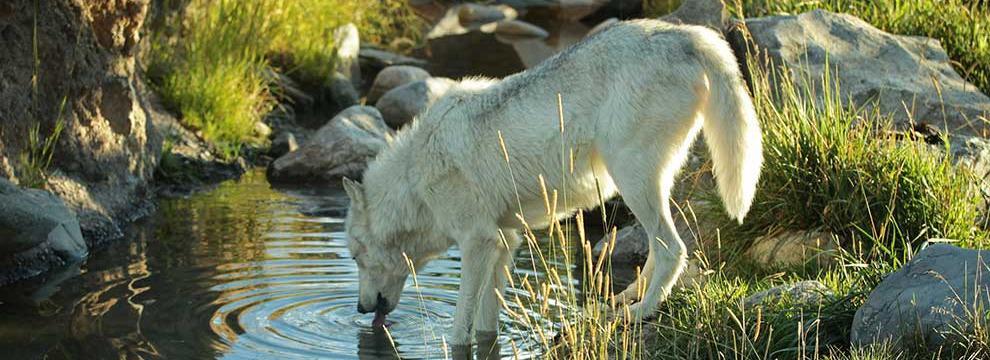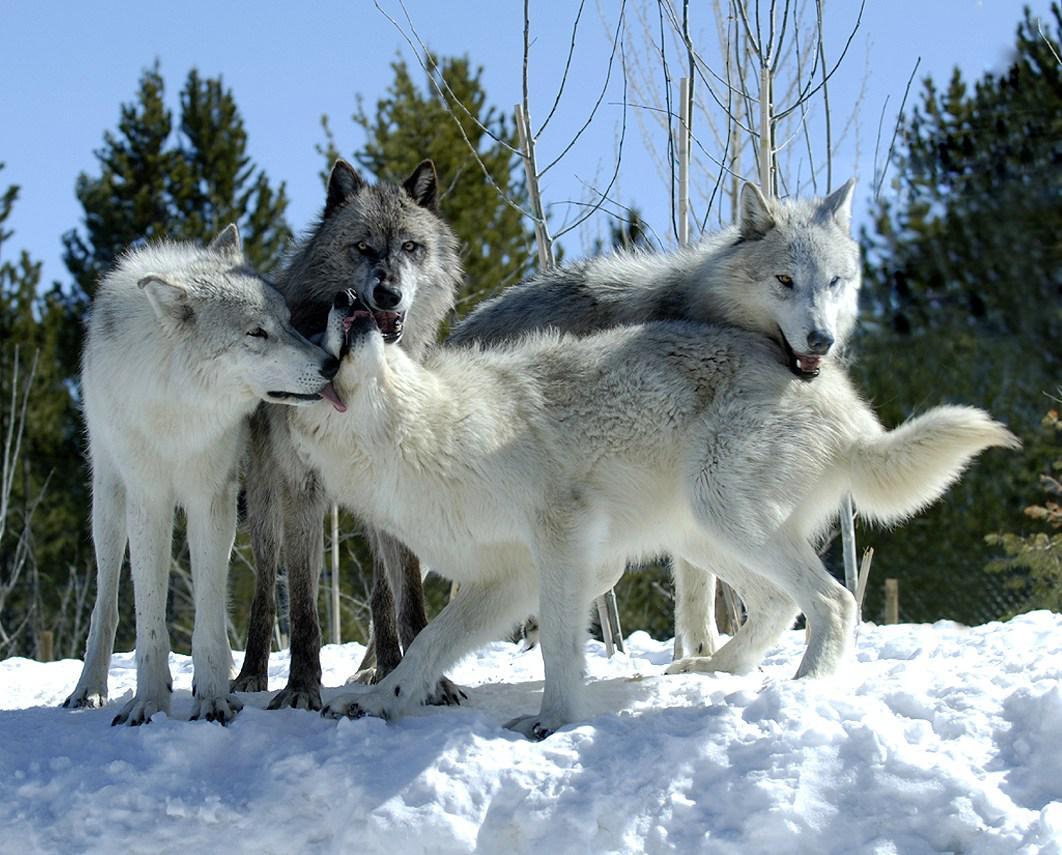The first image is the image on the left, the second image is the image on the right. Examine the images to the left and right. Is the description "At least one dog has its front paws standing in a pool of water surrounded by rocks and green grass." accurate? Answer yes or no. Yes. The first image is the image on the left, the second image is the image on the right. Considering the images on both sides, is "There is exactly four wolves in the right image." valid? Answer yes or no. Yes. 